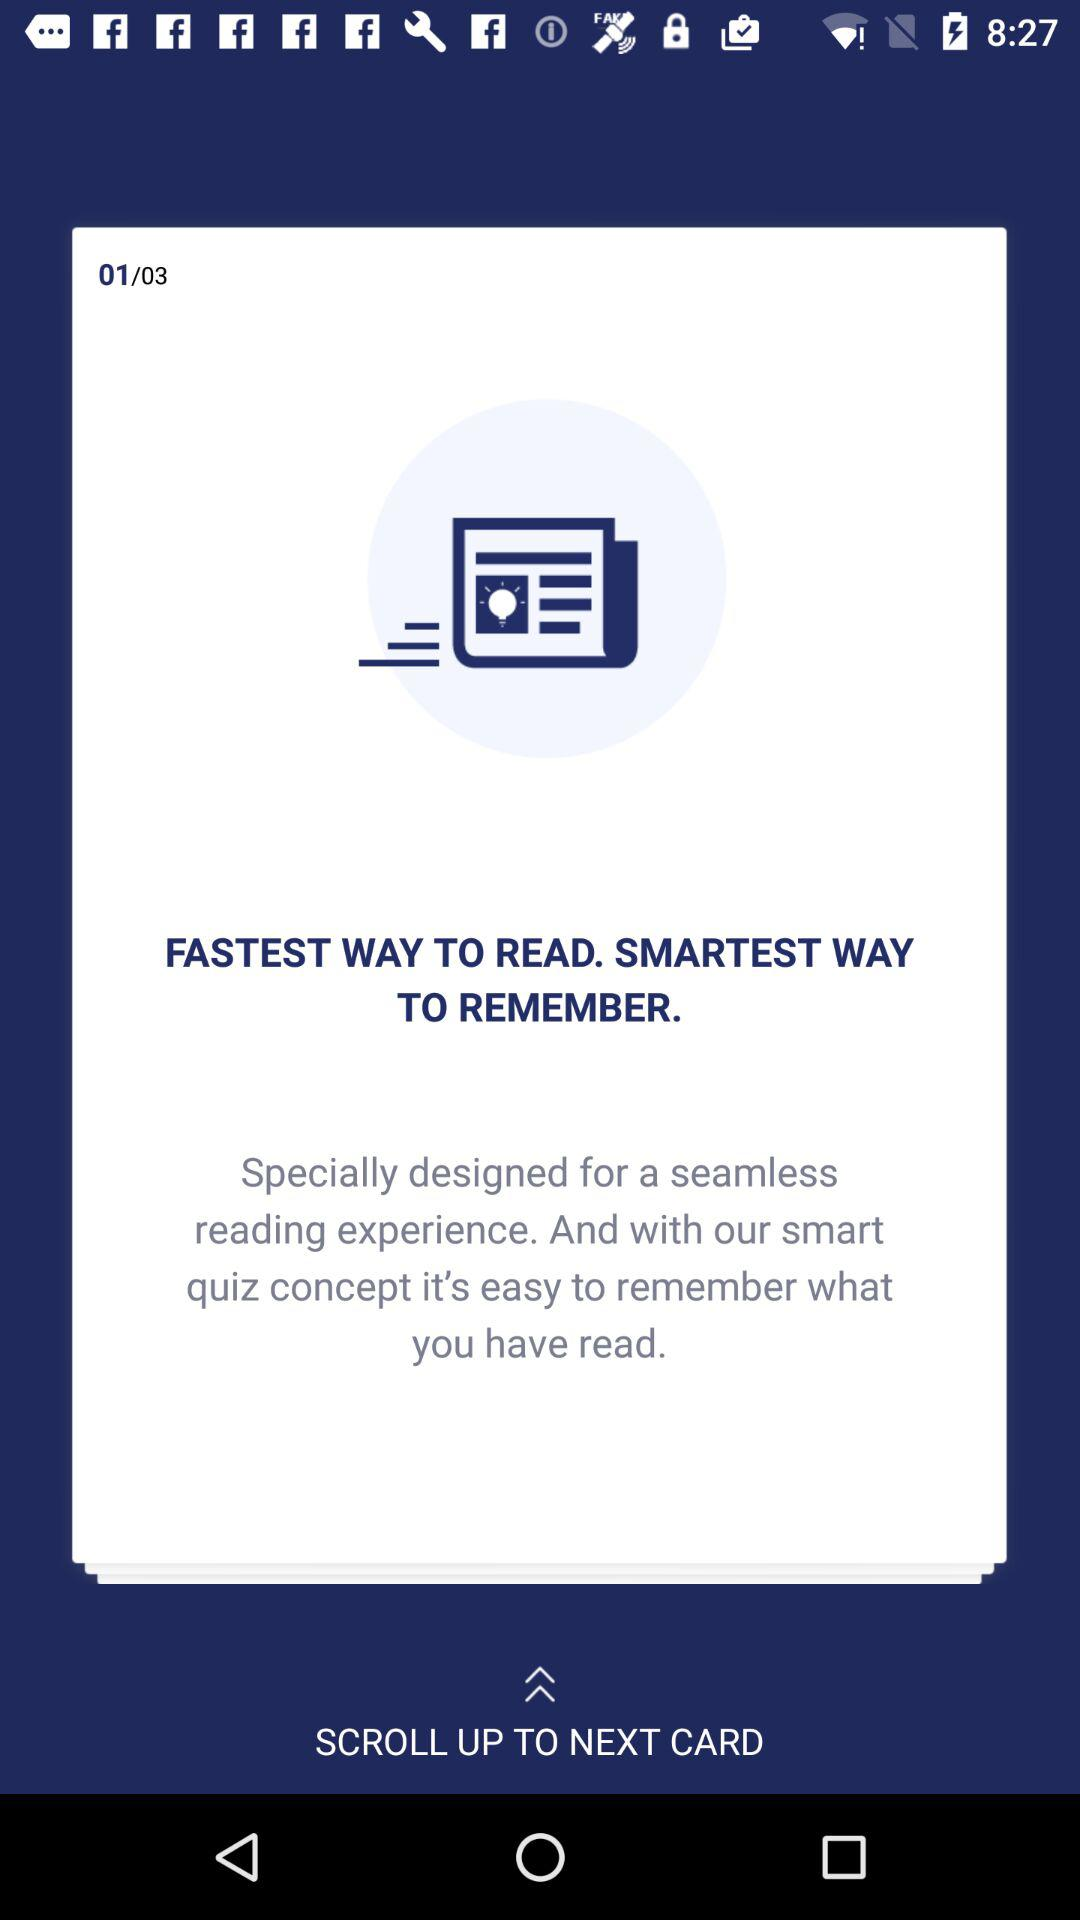Which card number am I on? You are on the first card. 